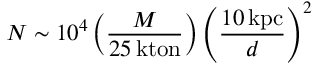Convert formula to latex. <formula><loc_0><loc_0><loc_500><loc_500>N \sim 1 0 ^ { 4 } \left ( { \frac { M } { 2 5 \, k t o n } } \right ) \left ( { \frac { 1 0 \, k p c } { d } } \right ) ^ { 2 }</formula> 